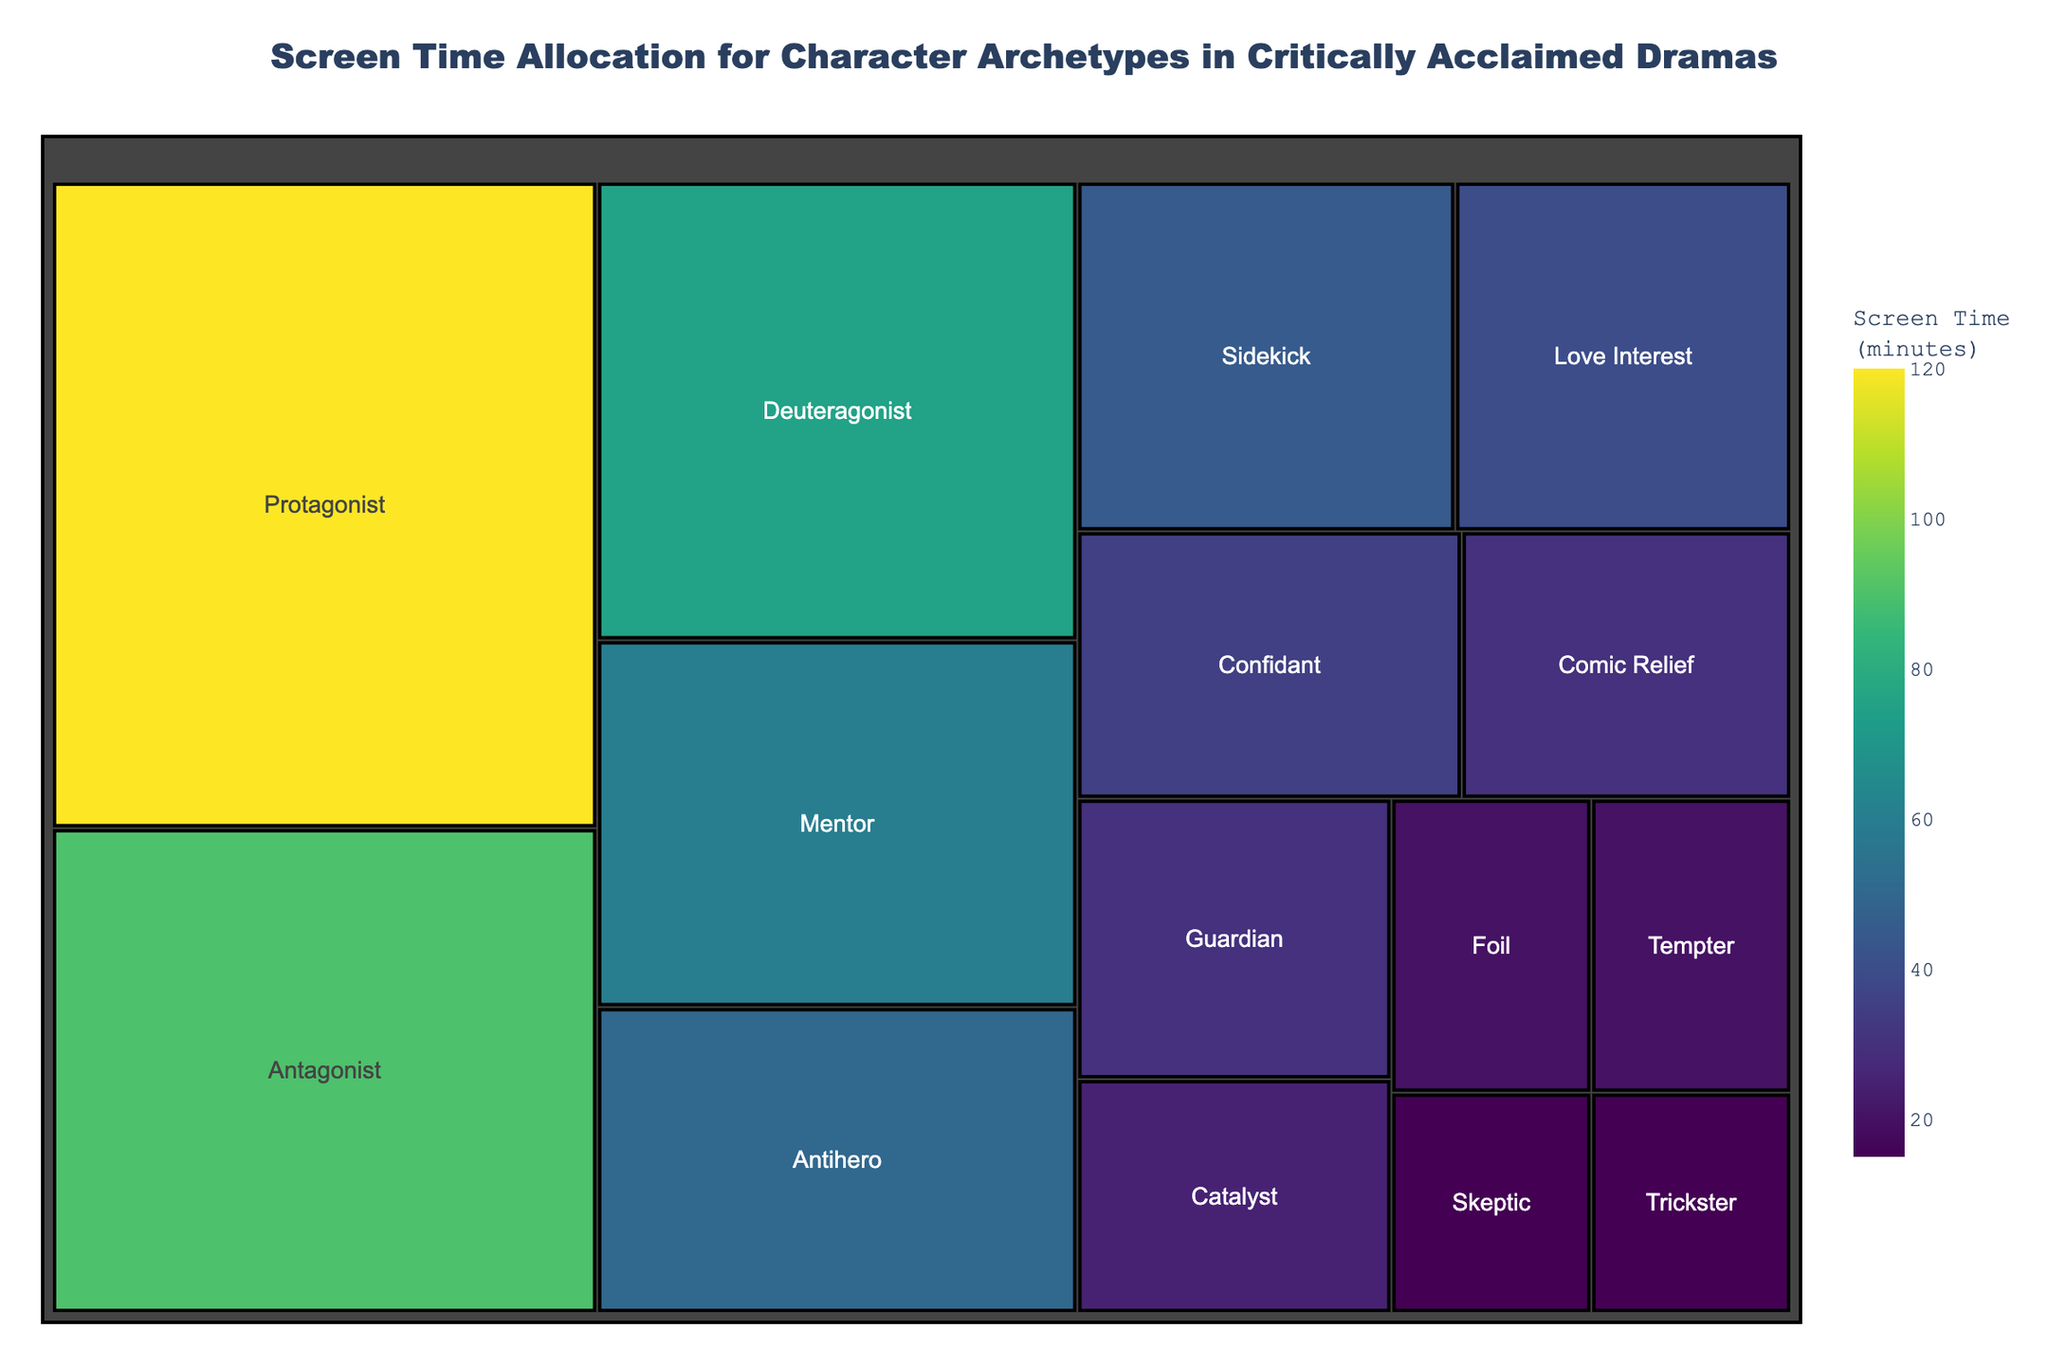What's the title of the treemap? The title is typically displayed prominently at the top of the treemap plot. By reading it, we can determine the main subject of the visualization.
Answer: Screen Time Allocation for Character Archetypes in Critically Acclaimed Dramas Which character archetype has the largest screen time? The largest section in the treemap will represent the character archetype with the highest screen time, as treemaps encode data using area.
Answer: Protagonist Which character archetype has the smallest screen time? The smallest section in the treemap will represent the character archetype with the lowest screen time.
Answer: Trickster or Skeptic (both have 15 minutes) What is the total screen time allocation for the Protagonist and Antagonist? To find the total screen time allocation for two character archetypes, sum their respective screen times. Protagonist has 120 minutes, and Antagonist has 90 minutes. \( 120 + 90 = 210 \).
Answer: 210 minutes How does the screen time of the Mentor compare to the Deuteragonist? Compare the size of their respective sections or their screen times directly. Mentor has 60 minutes, and Deuteragonist has 75 minutes.
Answer: Deuteragonist has more screen time than Mentor What is the combined screen time of the Comic Relief, Confidant, and Catalyst characters? Add their respective screen times. Comic Relief has 30 minutes, Confidant has 35 minutes, and Catalyst has 25 minutes. \( 30 + 35 + 25 = 90 \).
Answer: 90 minutes Which character archetype gets more screen time, the Love Interest or the Antihero? Compare the respective screen times. Love Interest has 40 minutes, and Antihero has 50 minutes.
Answer: Antihero What is the average screen time of the Guardian, Tempter, and Skeptic characters? Calculate the sum of their screen times and divide it by the number of characters. Guardian has 30 minutes, Tempter has 20 minutes, and Skeptic has 15 minutes. \( (30 + 20 + 15) / 3 = 65 / 3 \approx 21.67 \).
Answer: Approximately 21.67 minutes Which character archetype has a screen time closest to 50 minutes? Look for the section labeled with screen times around 50 minutes in the treemap.
Answer: Antihero What is the difference in screen time between the Sidekick and the Mentor characters? Subtract the screen time of the Sidekick from that of the Mentor. Mentor has 60 minutes, and Sidekick has 45 minutes. \( 60 - 45 = 15 \).
Answer: 15 minutes 